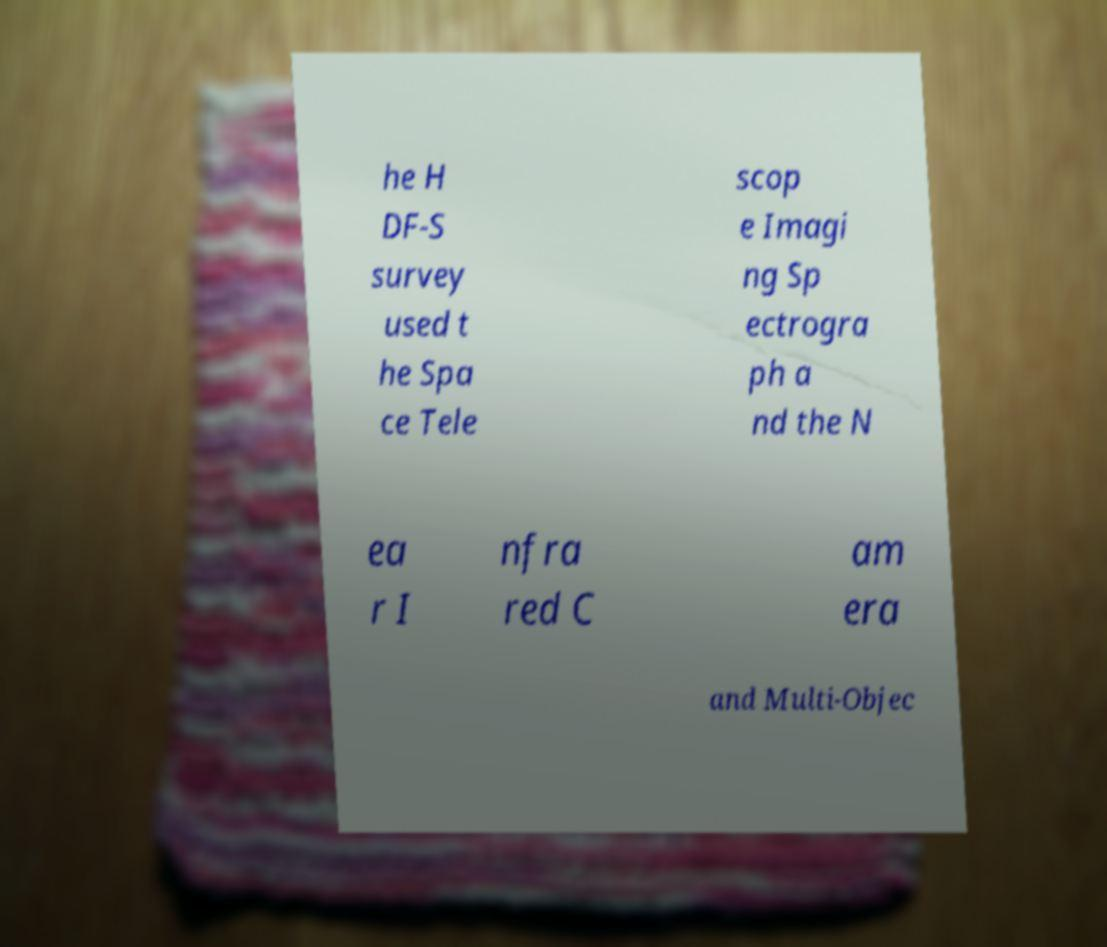Please read and relay the text visible in this image. What does it say? he H DF-S survey used t he Spa ce Tele scop e Imagi ng Sp ectrogra ph a nd the N ea r I nfra red C am era and Multi-Objec 